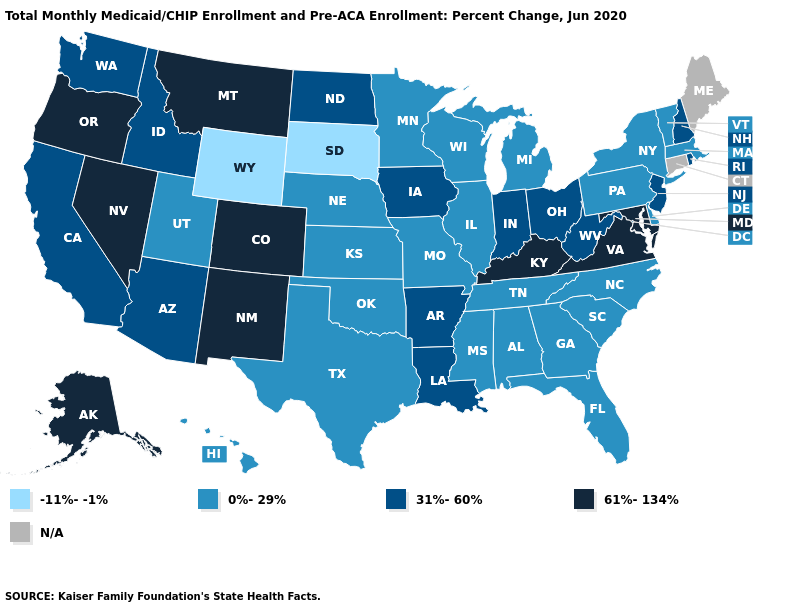What is the highest value in states that border Wisconsin?
Keep it brief. 31%-60%. What is the value of Arkansas?
Be succinct. 31%-60%. What is the value of Wisconsin?
Keep it brief. 0%-29%. Name the states that have a value in the range 0%-29%?
Concise answer only. Alabama, Delaware, Florida, Georgia, Hawaii, Illinois, Kansas, Massachusetts, Michigan, Minnesota, Mississippi, Missouri, Nebraska, New York, North Carolina, Oklahoma, Pennsylvania, South Carolina, Tennessee, Texas, Utah, Vermont, Wisconsin. What is the value of North Carolina?
Short answer required. 0%-29%. Name the states that have a value in the range N/A?
Be succinct. Connecticut, Maine. What is the value of Georgia?
Short answer required. 0%-29%. Which states have the lowest value in the USA?
Be succinct. South Dakota, Wyoming. Which states have the lowest value in the MidWest?
Be succinct. South Dakota. How many symbols are there in the legend?
Concise answer only. 5. What is the value of Wisconsin?
Answer briefly. 0%-29%. What is the value of Washington?
Answer briefly. 31%-60%. Name the states that have a value in the range N/A?
Quick response, please. Connecticut, Maine. 